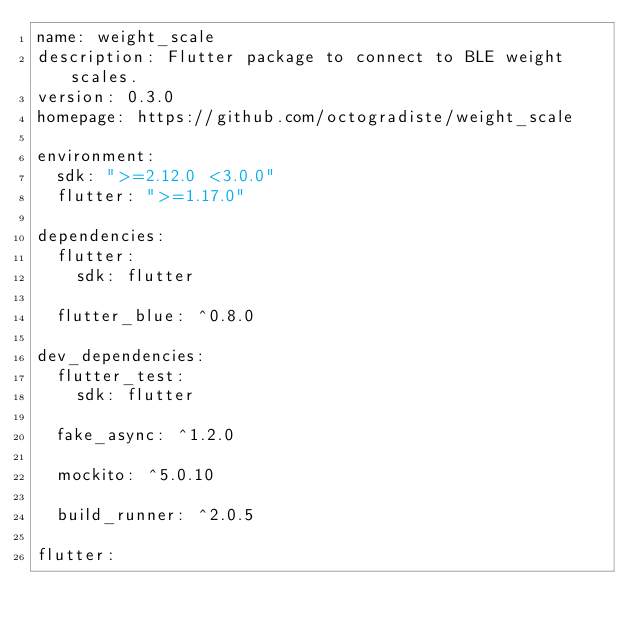<code> <loc_0><loc_0><loc_500><loc_500><_YAML_>name: weight_scale
description: Flutter package to connect to BLE weight scales.
version: 0.3.0
homepage: https://github.com/octogradiste/weight_scale

environment:
  sdk: ">=2.12.0 <3.0.0"
  flutter: ">=1.17.0"

dependencies:
  flutter:
    sdk: flutter

  flutter_blue: ^0.8.0

dev_dependencies:
  flutter_test:
    sdk: flutter

  fake_async: ^1.2.0

  mockito: ^5.0.10

  build_runner: ^2.0.5

flutter:
</code> 